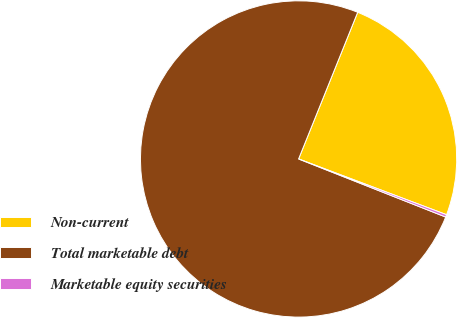Convert chart. <chart><loc_0><loc_0><loc_500><loc_500><pie_chart><fcel>Non-current<fcel>Total marketable debt<fcel>Marketable equity securities<nl><fcel>24.64%<fcel>75.11%<fcel>0.25%<nl></chart> 